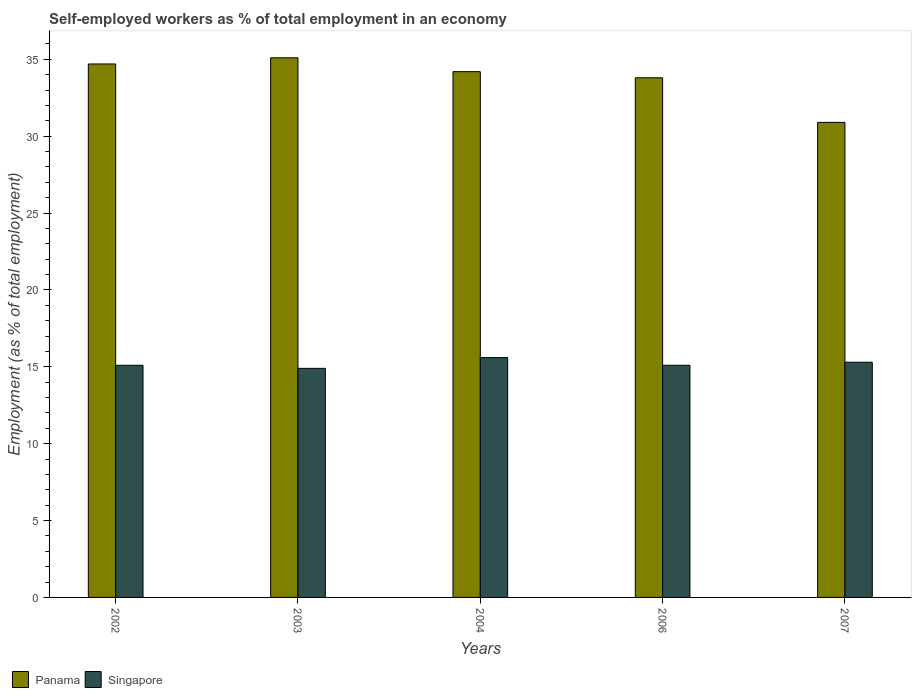Are the number of bars per tick equal to the number of legend labels?
Offer a very short reply. Yes. Are the number of bars on each tick of the X-axis equal?
Your response must be concise. Yes. How many bars are there on the 5th tick from the left?
Offer a very short reply. 2. In how many cases, is the number of bars for a given year not equal to the number of legend labels?
Make the answer very short. 0. What is the percentage of self-employed workers in Singapore in 2004?
Offer a terse response. 15.6. Across all years, what is the maximum percentage of self-employed workers in Panama?
Offer a terse response. 35.1. Across all years, what is the minimum percentage of self-employed workers in Singapore?
Keep it short and to the point. 14.9. What is the total percentage of self-employed workers in Panama in the graph?
Provide a short and direct response. 168.7. What is the difference between the percentage of self-employed workers in Panama in 2006 and that in 2007?
Keep it short and to the point. 2.9. What is the difference between the percentage of self-employed workers in Panama in 2003 and the percentage of self-employed workers in Singapore in 2006?
Your answer should be very brief. 20. What is the average percentage of self-employed workers in Singapore per year?
Make the answer very short. 15.2. In the year 2003, what is the difference between the percentage of self-employed workers in Singapore and percentage of self-employed workers in Panama?
Make the answer very short. -20.2. What is the ratio of the percentage of self-employed workers in Singapore in 2004 to that in 2007?
Offer a terse response. 1.02. What is the difference between the highest and the second highest percentage of self-employed workers in Singapore?
Your answer should be very brief. 0.3. What is the difference between the highest and the lowest percentage of self-employed workers in Panama?
Your answer should be compact. 4.2. Is the sum of the percentage of self-employed workers in Singapore in 2002 and 2007 greater than the maximum percentage of self-employed workers in Panama across all years?
Make the answer very short. No. What does the 1st bar from the left in 2004 represents?
Your response must be concise. Panama. What does the 2nd bar from the right in 2007 represents?
Offer a terse response. Panama. How many bars are there?
Provide a short and direct response. 10. How many years are there in the graph?
Make the answer very short. 5. Are the values on the major ticks of Y-axis written in scientific E-notation?
Your response must be concise. No. How are the legend labels stacked?
Your answer should be compact. Horizontal. What is the title of the graph?
Offer a very short reply. Self-employed workers as % of total employment in an economy. Does "Libya" appear as one of the legend labels in the graph?
Give a very brief answer. No. What is the label or title of the X-axis?
Offer a terse response. Years. What is the label or title of the Y-axis?
Ensure brevity in your answer.  Employment (as % of total employment). What is the Employment (as % of total employment) in Panama in 2002?
Your response must be concise. 34.7. What is the Employment (as % of total employment) in Singapore in 2002?
Your answer should be compact. 15.1. What is the Employment (as % of total employment) of Panama in 2003?
Give a very brief answer. 35.1. What is the Employment (as % of total employment) of Singapore in 2003?
Your response must be concise. 14.9. What is the Employment (as % of total employment) of Panama in 2004?
Provide a short and direct response. 34.2. What is the Employment (as % of total employment) in Singapore in 2004?
Offer a terse response. 15.6. What is the Employment (as % of total employment) in Panama in 2006?
Provide a succinct answer. 33.8. What is the Employment (as % of total employment) in Singapore in 2006?
Give a very brief answer. 15.1. What is the Employment (as % of total employment) in Panama in 2007?
Ensure brevity in your answer.  30.9. What is the Employment (as % of total employment) in Singapore in 2007?
Ensure brevity in your answer.  15.3. Across all years, what is the maximum Employment (as % of total employment) of Panama?
Keep it short and to the point. 35.1. Across all years, what is the maximum Employment (as % of total employment) of Singapore?
Give a very brief answer. 15.6. Across all years, what is the minimum Employment (as % of total employment) of Panama?
Your answer should be compact. 30.9. Across all years, what is the minimum Employment (as % of total employment) of Singapore?
Keep it short and to the point. 14.9. What is the total Employment (as % of total employment) in Panama in the graph?
Keep it short and to the point. 168.7. What is the difference between the Employment (as % of total employment) of Singapore in 2002 and that in 2003?
Offer a terse response. 0.2. What is the difference between the Employment (as % of total employment) of Panama in 2002 and that in 2004?
Provide a succinct answer. 0.5. What is the difference between the Employment (as % of total employment) in Singapore in 2002 and that in 2004?
Give a very brief answer. -0.5. What is the difference between the Employment (as % of total employment) in Singapore in 2002 and that in 2006?
Your answer should be very brief. 0. What is the difference between the Employment (as % of total employment) in Singapore in 2003 and that in 2004?
Your response must be concise. -0.7. What is the difference between the Employment (as % of total employment) in Panama in 2004 and that in 2006?
Offer a terse response. 0.4. What is the difference between the Employment (as % of total employment) of Panama in 2004 and that in 2007?
Your response must be concise. 3.3. What is the difference between the Employment (as % of total employment) in Singapore in 2006 and that in 2007?
Your answer should be very brief. -0.2. What is the difference between the Employment (as % of total employment) in Panama in 2002 and the Employment (as % of total employment) in Singapore in 2003?
Your answer should be very brief. 19.8. What is the difference between the Employment (as % of total employment) of Panama in 2002 and the Employment (as % of total employment) of Singapore in 2004?
Offer a terse response. 19.1. What is the difference between the Employment (as % of total employment) of Panama in 2002 and the Employment (as % of total employment) of Singapore in 2006?
Your response must be concise. 19.6. What is the difference between the Employment (as % of total employment) of Panama in 2003 and the Employment (as % of total employment) of Singapore in 2004?
Provide a short and direct response. 19.5. What is the difference between the Employment (as % of total employment) of Panama in 2003 and the Employment (as % of total employment) of Singapore in 2006?
Your answer should be compact. 20. What is the difference between the Employment (as % of total employment) in Panama in 2003 and the Employment (as % of total employment) in Singapore in 2007?
Your answer should be very brief. 19.8. What is the difference between the Employment (as % of total employment) in Panama in 2004 and the Employment (as % of total employment) in Singapore in 2007?
Offer a terse response. 18.9. What is the average Employment (as % of total employment) of Panama per year?
Give a very brief answer. 33.74. In the year 2002, what is the difference between the Employment (as % of total employment) in Panama and Employment (as % of total employment) in Singapore?
Make the answer very short. 19.6. In the year 2003, what is the difference between the Employment (as % of total employment) in Panama and Employment (as % of total employment) in Singapore?
Offer a very short reply. 20.2. In the year 2004, what is the difference between the Employment (as % of total employment) of Panama and Employment (as % of total employment) of Singapore?
Make the answer very short. 18.6. In the year 2006, what is the difference between the Employment (as % of total employment) in Panama and Employment (as % of total employment) in Singapore?
Make the answer very short. 18.7. What is the ratio of the Employment (as % of total employment) in Panama in 2002 to that in 2003?
Your answer should be compact. 0.99. What is the ratio of the Employment (as % of total employment) of Singapore in 2002 to that in 2003?
Your answer should be very brief. 1.01. What is the ratio of the Employment (as % of total employment) in Panama in 2002 to that in 2004?
Make the answer very short. 1.01. What is the ratio of the Employment (as % of total employment) of Singapore in 2002 to that in 2004?
Offer a terse response. 0.97. What is the ratio of the Employment (as % of total employment) of Panama in 2002 to that in 2006?
Your response must be concise. 1.03. What is the ratio of the Employment (as % of total employment) of Singapore in 2002 to that in 2006?
Give a very brief answer. 1. What is the ratio of the Employment (as % of total employment) of Panama in 2002 to that in 2007?
Offer a terse response. 1.12. What is the ratio of the Employment (as % of total employment) of Singapore in 2002 to that in 2007?
Provide a short and direct response. 0.99. What is the ratio of the Employment (as % of total employment) of Panama in 2003 to that in 2004?
Ensure brevity in your answer.  1.03. What is the ratio of the Employment (as % of total employment) of Singapore in 2003 to that in 2004?
Provide a succinct answer. 0.96. What is the ratio of the Employment (as % of total employment) of Singapore in 2003 to that in 2006?
Give a very brief answer. 0.99. What is the ratio of the Employment (as % of total employment) in Panama in 2003 to that in 2007?
Provide a short and direct response. 1.14. What is the ratio of the Employment (as % of total employment) of Singapore in 2003 to that in 2007?
Your response must be concise. 0.97. What is the ratio of the Employment (as % of total employment) of Panama in 2004 to that in 2006?
Your answer should be compact. 1.01. What is the ratio of the Employment (as % of total employment) in Singapore in 2004 to that in 2006?
Offer a terse response. 1.03. What is the ratio of the Employment (as % of total employment) in Panama in 2004 to that in 2007?
Keep it short and to the point. 1.11. What is the ratio of the Employment (as % of total employment) of Singapore in 2004 to that in 2007?
Ensure brevity in your answer.  1.02. What is the ratio of the Employment (as % of total employment) of Panama in 2006 to that in 2007?
Your response must be concise. 1.09. What is the ratio of the Employment (as % of total employment) of Singapore in 2006 to that in 2007?
Offer a very short reply. 0.99. What is the difference between the highest and the second highest Employment (as % of total employment) in Singapore?
Ensure brevity in your answer.  0.3. 